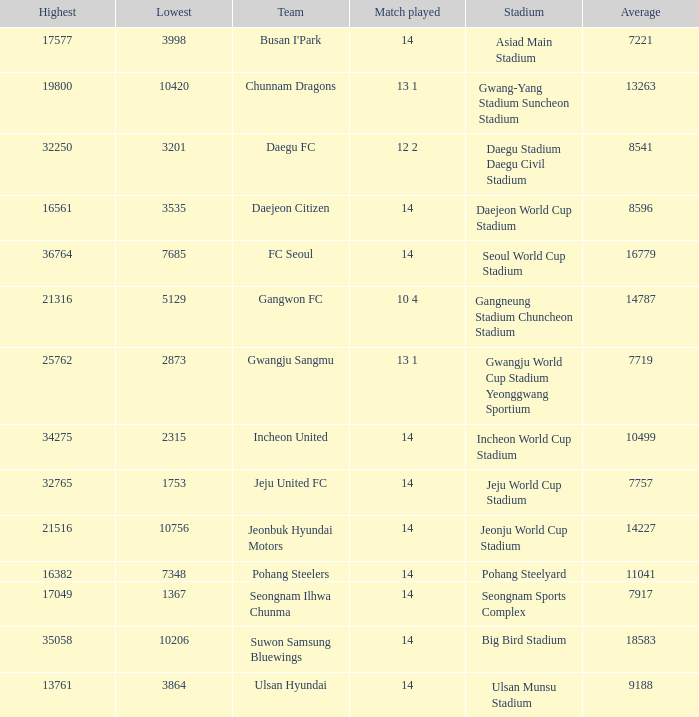Which team has 7757 as the average? Jeju United FC. 